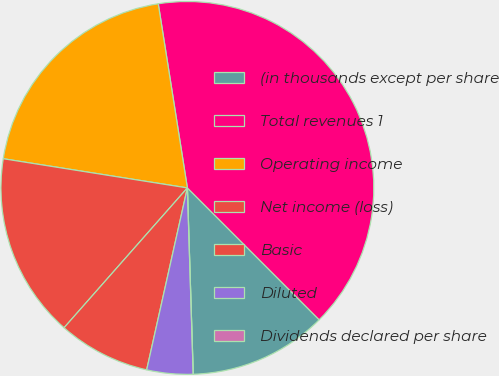Convert chart to OTSL. <chart><loc_0><loc_0><loc_500><loc_500><pie_chart><fcel>(in thousands except per share<fcel>Total revenues 1<fcel>Operating income<fcel>Net income (loss)<fcel>Basic<fcel>Diluted<fcel>Dividends declared per share<nl><fcel>12.0%<fcel>40.0%<fcel>20.0%<fcel>16.0%<fcel>8.0%<fcel>4.0%<fcel>0.0%<nl></chart> 